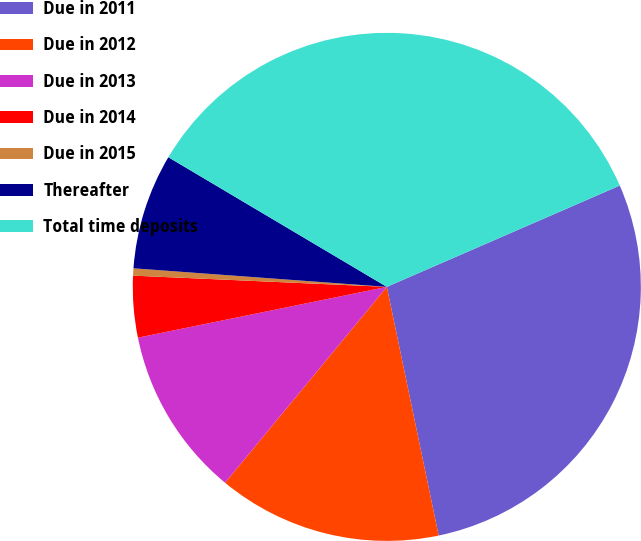<chart> <loc_0><loc_0><loc_500><loc_500><pie_chart><fcel>Due in 2011<fcel>Due in 2012<fcel>Due in 2013<fcel>Due in 2014<fcel>Due in 2015<fcel>Thereafter<fcel>Total time deposits<nl><fcel>28.26%<fcel>14.26%<fcel>10.81%<fcel>3.91%<fcel>0.46%<fcel>7.36%<fcel>34.95%<nl></chart> 